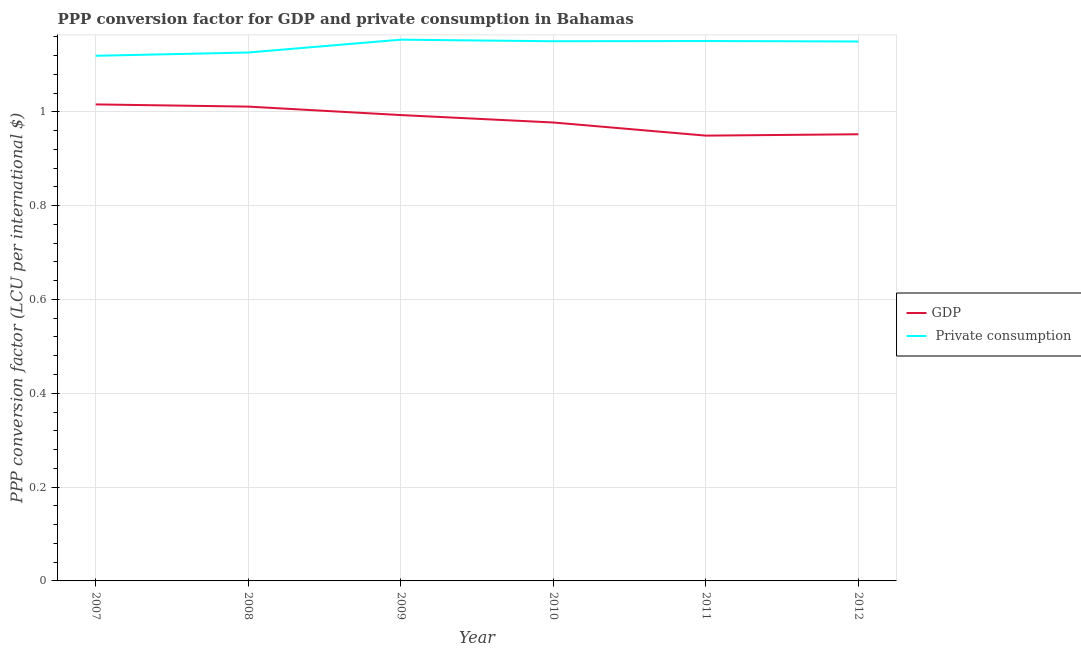Does the line corresponding to ppp conversion factor for private consumption intersect with the line corresponding to ppp conversion factor for gdp?
Provide a succinct answer. No. Is the number of lines equal to the number of legend labels?
Your response must be concise. Yes. What is the ppp conversion factor for gdp in 2009?
Provide a succinct answer. 0.99. Across all years, what is the maximum ppp conversion factor for gdp?
Give a very brief answer. 1.02. Across all years, what is the minimum ppp conversion factor for private consumption?
Keep it short and to the point. 1.12. In which year was the ppp conversion factor for private consumption minimum?
Offer a terse response. 2007. What is the total ppp conversion factor for private consumption in the graph?
Offer a very short reply. 6.85. What is the difference between the ppp conversion factor for gdp in 2007 and that in 2010?
Offer a terse response. 0.04. What is the difference between the ppp conversion factor for gdp in 2010 and the ppp conversion factor for private consumption in 2009?
Make the answer very short. -0.18. What is the average ppp conversion factor for private consumption per year?
Offer a terse response. 1.14. In the year 2008, what is the difference between the ppp conversion factor for gdp and ppp conversion factor for private consumption?
Keep it short and to the point. -0.12. In how many years, is the ppp conversion factor for gdp greater than 0.12 LCU?
Make the answer very short. 6. What is the ratio of the ppp conversion factor for private consumption in 2008 to that in 2011?
Give a very brief answer. 0.98. What is the difference between the highest and the second highest ppp conversion factor for gdp?
Your answer should be compact. 0. What is the difference between the highest and the lowest ppp conversion factor for gdp?
Your answer should be very brief. 0.07. Is the ppp conversion factor for private consumption strictly greater than the ppp conversion factor for gdp over the years?
Ensure brevity in your answer.  Yes. How many lines are there?
Your response must be concise. 2. How many years are there in the graph?
Your answer should be very brief. 6. What is the difference between two consecutive major ticks on the Y-axis?
Your response must be concise. 0.2. Are the values on the major ticks of Y-axis written in scientific E-notation?
Offer a very short reply. No. Where does the legend appear in the graph?
Offer a very short reply. Center right. How many legend labels are there?
Your answer should be very brief. 2. What is the title of the graph?
Provide a succinct answer. PPP conversion factor for GDP and private consumption in Bahamas. Does "Investment" appear as one of the legend labels in the graph?
Your response must be concise. No. What is the label or title of the X-axis?
Provide a short and direct response. Year. What is the label or title of the Y-axis?
Give a very brief answer. PPP conversion factor (LCU per international $). What is the PPP conversion factor (LCU per international $) in GDP in 2007?
Keep it short and to the point. 1.02. What is the PPP conversion factor (LCU per international $) in  Private consumption in 2007?
Your answer should be compact. 1.12. What is the PPP conversion factor (LCU per international $) of GDP in 2008?
Give a very brief answer. 1.01. What is the PPP conversion factor (LCU per international $) of  Private consumption in 2008?
Your response must be concise. 1.13. What is the PPP conversion factor (LCU per international $) of GDP in 2009?
Offer a terse response. 0.99. What is the PPP conversion factor (LCU per international $) of  Private consumption in 2009?
Provide a succinct answer. 1.15. What is the PPP conversion factor (LCU per international $) of GDP in 2010?
Ensure brevity in your answer.  0.98. What is the PPP conversion factor (LCU per international $) in  Private consumption in 2010?
Offer a very short reply. 1.15. What is the PPP conversion factor (LCU per international $) of GDP in 2011?
Offer a very short reply. 0.95. What is the PPP conversion factor (LCU per international $) of  Private consumption in 2011?
Your response must be concise. 1.15. What is the PPP conversion factor (LCU per international $) in GDP in 2012?
Provide a succinct answer. 0.95. What is the PPP conversion factor (LCU per international $) in  Private consumption in 2012?
Offer a terse response. 1.15. Across all years, what is the maximum PPP conversion factor (LCU per international $) of GDP?
Your response must be concise. 1.02. Across all years, what is the maximum PPP conversion factor (LCU per international $) of  Private consumption?
Make the answer very short. 1.15. Across all years, what is the minimum PPP conversion factor (LCU per international $) in GDP?
Your response must be concise. 0.95. Across all years, what is the minimum PPP conversion factor (LCU per international $) of  Private consumption?
Keep it short and to the point. 1.12. What is the total PPP conversion factor (LCU per international $) in GDP in the graph?
Provide a succinct answer. 5.9. What is the total PPP conversion factor (LCU per international $) of  Private consumption in the graph?
Offer a terse response. 6.85. What is the difference between the PPP conversion factor (LCU per international $) of GDP in 2007 and that in 2008?
Provide a short and direct response. 0. What is the difference between the PPP conversion factor (LCU per international $) in  Private consumption in 2007 and that in 2008?
Provide a succinct answer. -0.01. What is the difference between the PPP conversion factor (LCU per international $) in GDP in 2007 and that in 2009?
Offer a very short reply. 0.02. What is the difference between the PPP conversion factor (LCU per international $) of  Private consumption in 2007 and that in 2009?
Ensure brevity in your answer.  -0.03. What is the difference between the PPP conversion factor (LCU per international $) of GDP in 2007 and that in 2010?
Offer a terse response. 0.04. What is the difference between the PPP conversion factor (LCU per international $) in  Private consumption in 2007 and that in 2010?
Provide a short and direct response. -0.03. What is the difference between the PPP conversion factor (LCU per international $) in GDP in 2007 and that in 2011?
Offer a terse response. 0.07. What is the difference between the PPP conversion factor (LCU per international $) in  Private consumption in 2007 and that in 2011?
Your answer should be very brief. -0.03. What is the difference between the PPP conversion factor (LCU per international $) in GDP in 2007 and that in 2012?
Your answer should be compact. 0.06. What is the difference between the PPP conversion factor (LCU per international $) of  Private consumption in 2007 and that in 2012?
Provide a short and direct response. -0.03. What is the difference between the PPP conversion factor (LCU per international $) of GDP in 2008 and that in 2009?
Provide a succinct answer. 0.02. What is the difference between the PPP conversion factor (LCU per international $) in  Private consumption in 2008 and that in 2009?
Provide a short and direct response. -0.03. What is the difference between the PPP conversion factor (LCU per international $) of GDP in 2008 and that in 2010?
Your response must be concise. 0.03. What is the difference between the PPP conversion factor (LCU per international $) in  Private consumption in 2008 and that in 2010?
Provide a short and direct response. -0.02. What is the difference between the PPP conversion factor (LCU per international $) in GDP in 2008 and that in 2011?
Provide a short and direct response. 0.06. What is the difference between the PPP conversion factor (LCU per international $) of  Private consumption in 2008 and that in 2011?
Your answer should be very brief. -0.02. What is the difference between the PPP conversion factor (LCU per international $) in GDP in 2008 and that in 2012?
Ensure brevity in your answer.  0.06. What is the difference between the PPP conversion factor (LCU per international $) in  Private consumption in 2008 and that in 2012?
Make the answer very short. -0.02. What is the difference between the PPP conversion factor (LCU per international $) of GDP in 2009 and that in 2010?
Offer a terse response. 0.02. What is the difference between the PPP conversion factor (LCU per international $) in  Private consumption in 2009 and that in 2010?
Give a very brief answer. 0. What is the difference between the PPP conversion factor (LCU per international $) in GDP in 2009 and that in 2011?
Ensure brevity in your answer.  0.04. What is the difference between the PPP conversion factor (LCU per international $) in  Private consumption in 2009 and that in 2011?
Provide a short and direct response. 0. What is the difference between the PPP conversion factor (LCU per international $) in GDP in 2009 and that in 2012?
Make the answer very short. 0.04. What is the difference between the PPP conversion factor (LCU per international $) in  Private consumption in 2009 and that in 2012?
Your answer should be compact. 0. What is the difference between the PPP conversion factor (LCU per international $) in GDP in 2010 and that in 2011?
Your answer should be very brief. 0.03. What is the difference between the PPP conversion factor (LCU per international $) in  Private consumption in 2010 and that in 2011?
Give a very brief answer. -0. What is the difference between the PPP conversion factor (LCU per international $) of GDP in 2010 and that in 2012?
Your response must be concise. 0.03. What is the difference between the PPP conversion factor (LCU per international $) in  Private consumption in 2010 and that in 2012?
Provide a succinct answer. 0. What is the difference between the PPP conversion factor (LCU per international $) in GDP in 2011 and that in 2012?
Your answer should be very brief. -0. What is the difference between the PPP conversion factor (LCU per international $) of GDP in 2007 and the PPP conversion factor (LCU per international $) of  Private consumption in 2008?
Offer a very short reply. -0.11. What is the difference between the PPP conversion factor (LCU per international $) in GDP in 2007 and the PPP conversion factor (LCU per international $) in  Private consumption in 2009?
Keep it short and to the point. -0.14. What is the difference between the PPP conversion factor (LCU per international $) in GDP in 2007 and the PPP conversion factor (LCU per international $) in  Private consumption in 2010?
Your answer should be compact. -0.13. What is the difference between the PPP conversion factor (LCU per international $) of GDP in 2007 and the PPP conversion factor (LCU per international $) of  Private consumption in 2011?
Offer a terse response. -0.14. What is the difference between the PPP conversion factor (LCU per international $) in GDP in 2007 and the PPP conversion factor (LCU per international $) in  Private consumption in 2012?
Offer a terse response. -0.13. What is the difference between the PPP conversion factor (LCU per international $) in GDP in 2008 and the PPP conversion factor (LCU per international $) in  Private consumption in 2009?
Your answer should be compact. -0.14. What is the difference between the PPP conversion factor (LCU per international $) of GDP in 2008 and the PPP conversion factor (LCU per international $) of  Private consumption in 2010?
Your response must be concise. -0.14. What is the difference between the PPP conversion factor (LCU per international $) of GDP in 2008 and the PPP conversion factor (LCU per international $) of  Private consumption in 2011?
Offer a very short reply. -0.14. What is the difference between the PPP conversion factor (LCU per international $) of GDP in 2008 and the PPP conversion factor (LCU per international $) of  Private consumption in 2012?
Offer a terse response. -0.14. What is the difference between the PPP conversion factor (LCU per international $) in GDP in 2009 and the PPP conversion factor (LCU per international $) in  Private consumption in 2010?
Offer a terse response. -0.16. What is the difference between the PPP conversion factor (LCU per international $) of GDP in 2009 and the PPP conversion factor (LCU per international $) of  Private consumption in 2011?
Keep it short and to the point. -0.16. What is the difference between the PPP conversion factor (LCU per international $) in GDP in 2009 and the PPP conversion factor (LCU per international $) in  Private consumption in 2012?
Keep it short and to the point. -0.16. What is the difference between the PPP conversion factor (LCU per international $) of GDP in 2010 and the PPP conversion factor (LCU per international $) of  Private consumption in 2011?
Provide a succinct answer. -0.17. What is the difference between the PPP conversion factor (LCU per international $) of GDP in 2010 and the PPP conversion factor (LCU per international $) of  Private consumption in 2012?
Give a very brief answer. -0.17. What is the difference between the PPP conversion factor (LCU per international $) of GDP in 2011 and the PPP conversion factor (LCU per international $) of  Private consumption in 2012?
Your answer should be very brief. -0.2. What is the average PPP conversion factor (LCU per international $) of GDP per year?
Your answer should be compact. 0.98. What is the average PPP conversion factor (LCU per international $) of  Private consumption per year?
Your answer should be compact. 1.14. In the year 2007, what is the difference between the PPP conversion factor (LCU per international $) in GDP and PPP conversion factor (LCU per international $) in  Private consumption?
Keep it short and to the point. -0.1. In the year 2008, what is the difference between the PPP conversion factor (LCU per international $) in GDP and PPP conversion factor (LCU per international $) in  Private consumption?
Offer a terse response. -0.12. In the year 2009, what is the difference between the PPP conversion factor (LCU per international $) in GDP and PPP conversion factor (LCU per international $) in  Private consumption?
Give a very brief answer. -0.16. In the year 2010, what is the difference between the PPP conversion factor (LCU per international $) in GDP and PPP conversion factor (LCU per international $) in  Private consumption?
Provide a short and direct response. -0.17. In the year 2011, what is the difference between the PPP conversion factor (LCU per international $) in GDP and PPP conversion factor (LCU per international $) in  Private consumption?
Provide a succinct answer. -0.2. In the year 2012, what is the difference between the PPP conversion factor (LCU per international $) of GDP and PPP conversion factor (LCU per international $) of  Private consumption?
Your response must be concise. -0.2. What is the ratio of the PPP conversion factor (LCU per international $) of GDP in 2007 to that in 2009?
Provide a short and direct response. 1.02. What is the ratio of the PPP conversion factor (LCU per international $) in  Private consumption in 2007 to that in 2009?
Your answer should be very brief. 0.97. What is the ratio of the PPP conversion factor (LCU per international $) of GDP in 2007 to that in 2010?
Give a very brief answer. 1.04. What is the ratio of the PPP conversion factor (LCU per international $) in  Private consumption in 2007 to that in 2010?
Provide a succinct answer. 0.97. What is the ratio of the PPP conversion factor (LCU per international $) in GDP in 2007 to that in 2011?
Your answer should be compact. 1.07. What is the ratio of the PPP conversion factor (LCU per international $) in  Private consumption in 2007 to that in 2011?
Offer a terse response. 0.97. What is the ratio of the PPP conversion factor (LCU per international $) of GDP in 2007 to that in 2012?
Your answer should be compact. 1.07. What is the ratio of the PPP conversion factor (LCU per international $) of  Private consumption in 2007 to that in 2012?
Keep it short and to the point. 0.97. What is the ratio of the PPP conversion factor (LCU per international $) of GDP in 2008 to that in 2009?
Ensure brevity in your answer.  1.02. What is the ratio of the PPP conversion factor (LCU per international $) of  Private consumption in 2008 to that in 2009?
Give a very brief answer. 0.98. What is the ratio of the PPP conversion factor (LCU per international $) in GDP in 2008 to that in 2010?
Give a very brief answer. 1.03. What is the ratio of the PPP conversion factor (LCU per international $) of  Private consumption in 2008 to that in 2010?
Your response must be concise. 0.98. What is the ratio of the PPP conversion factor (LCU per international $) in GDP in 2008 to that in 2011?
Offer a terse response. 1.07. What is the ratio of the PPP conversion factor (LCU per international $) in  Private consumption in 2008 to that in 2011?
Your answer should be very brief. 0.98. What is the ratio of the PPP conversion factor (LCU per international $) of GDP in 2008 to that in 2012?
Offer a terse response. 1.06. What is the ratio of the PPP conversion factor (LCU per international $) of  Private consumption in 2008 to that in 2012?
Offer a terse response. 0.98. What is the ratio of the PPP conversion factor (LCU per international $) in GDP in 2009 to that in 2010?
Keep it short and to the point. 1.02. What is the ratio of the PPP conversion factor (LCU per international $) in GDP in 2009 to that in 2011?
Your response must be concise. 1.05. What is the ratio of the PPP conversion factor (LCU per international $) of GDP in 2009 to that in 2012?
Give a very brief answer. 1.04. What is the ratio of the PPP conversion factor (LCU per international $) in  Private consumption in 2009 to that in 2012?
Your response must be concise. 1. What is the ratio of the PPP conversion factor (LCU per international $) in GDP in 2010 to that in 2011?
Keep it short and to the point. 1.03. What is the ratio of the PPP conversion factor (LCU per international $) of GDP in 2010 to that in 2012?
Your answer should be very brief. 1.03. What is the ratio of the PPP conversion factor (LCU per international $) in  Private consumption in 2010 to that in 2012?
Provide a succinct answer. 1. What is the difference between the highest and the second highest PPP conversion factor (LCU per international $) in GDP?
Ensure brevity in your answer.  0. What is the difference between the highest and the second highest PPP conversion factor (LCU per international $) in  Private consumption?
Your response must be concise. 0. What is the difference between the highest and the lowest PPP conversion factor (LCU per international $) of GDP?
Give a very brief answer. 0.07. What is the difference between the highest and the lowest PPP conversion factor (LCU per international $) of  Private consumption?
Ensure brevity in your answer.  0.03. 